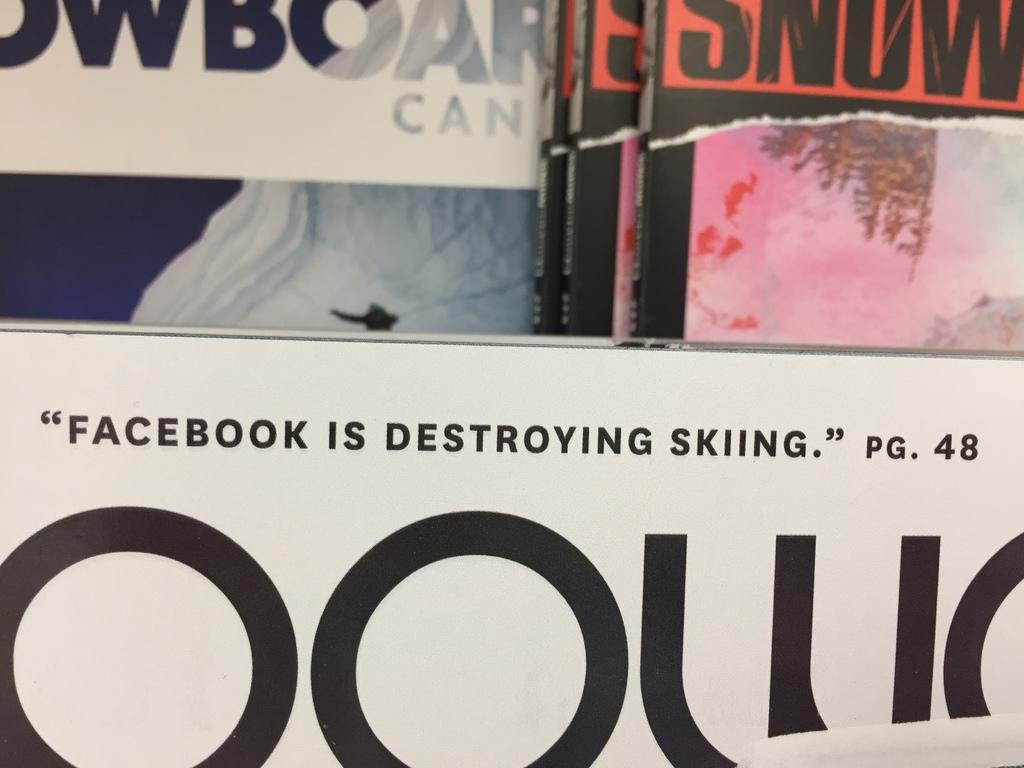What page is that on?
Your answer should be compact. 48. 